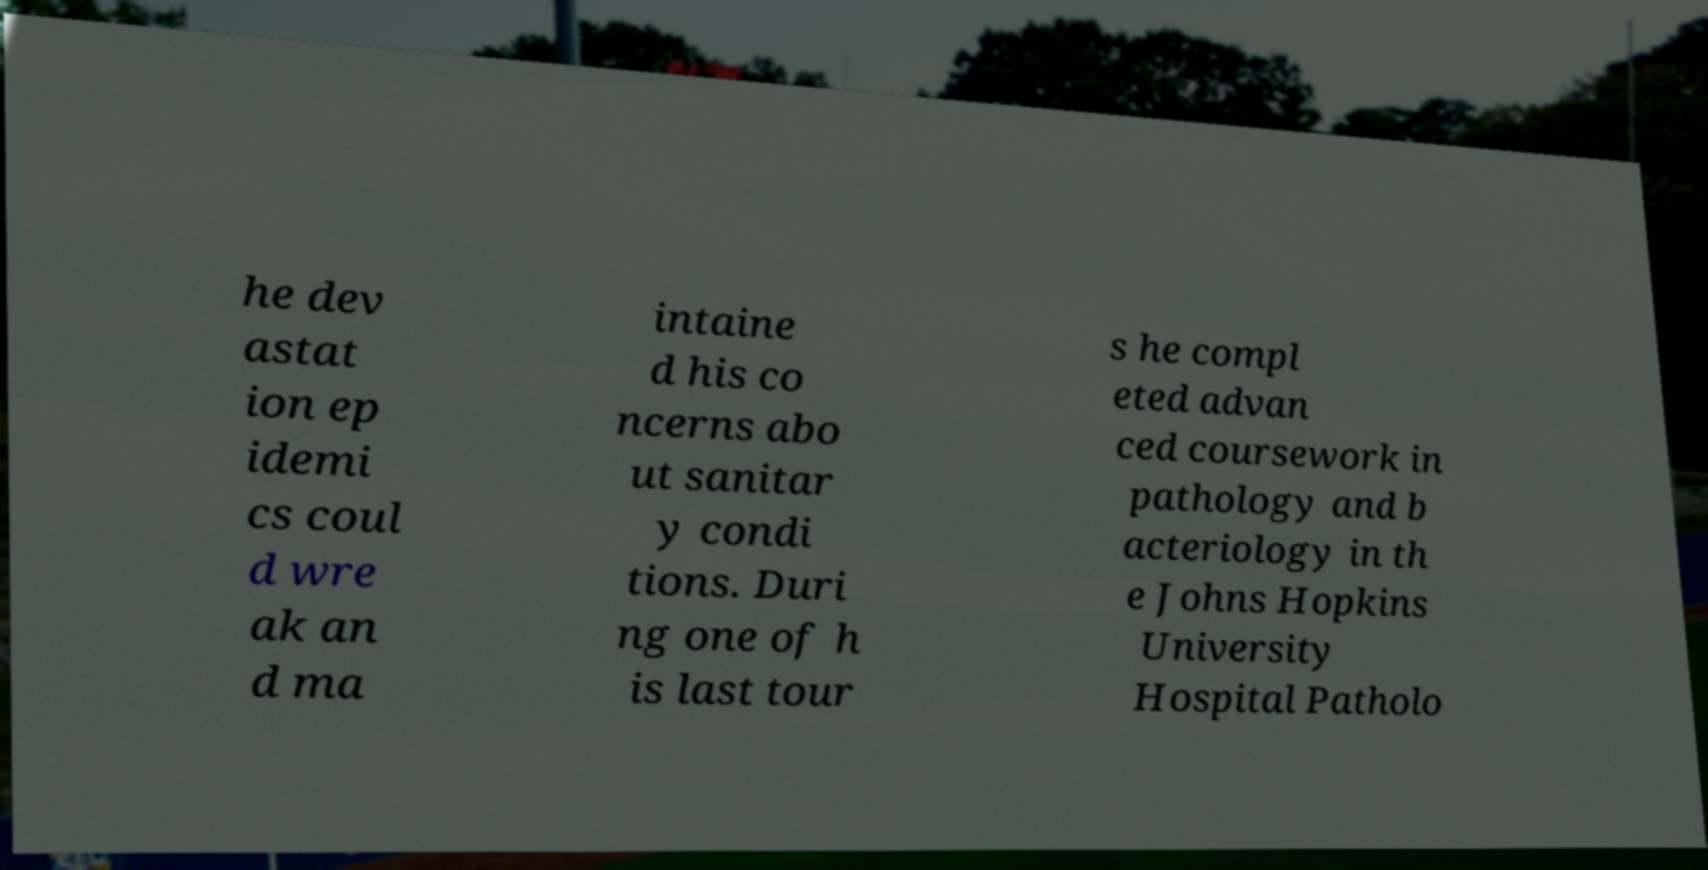Could you extract and type out the text from this image? he dev astat ion ep idemi cs coul d wre ak an d ma intaine d his co ncerns abo ut sanitar y condi tions. Duri ng one of h is last tour s he compl eted advan ced coursework in pathology and b acteriology in th e Johns Hopkins University Hospital Patholo 